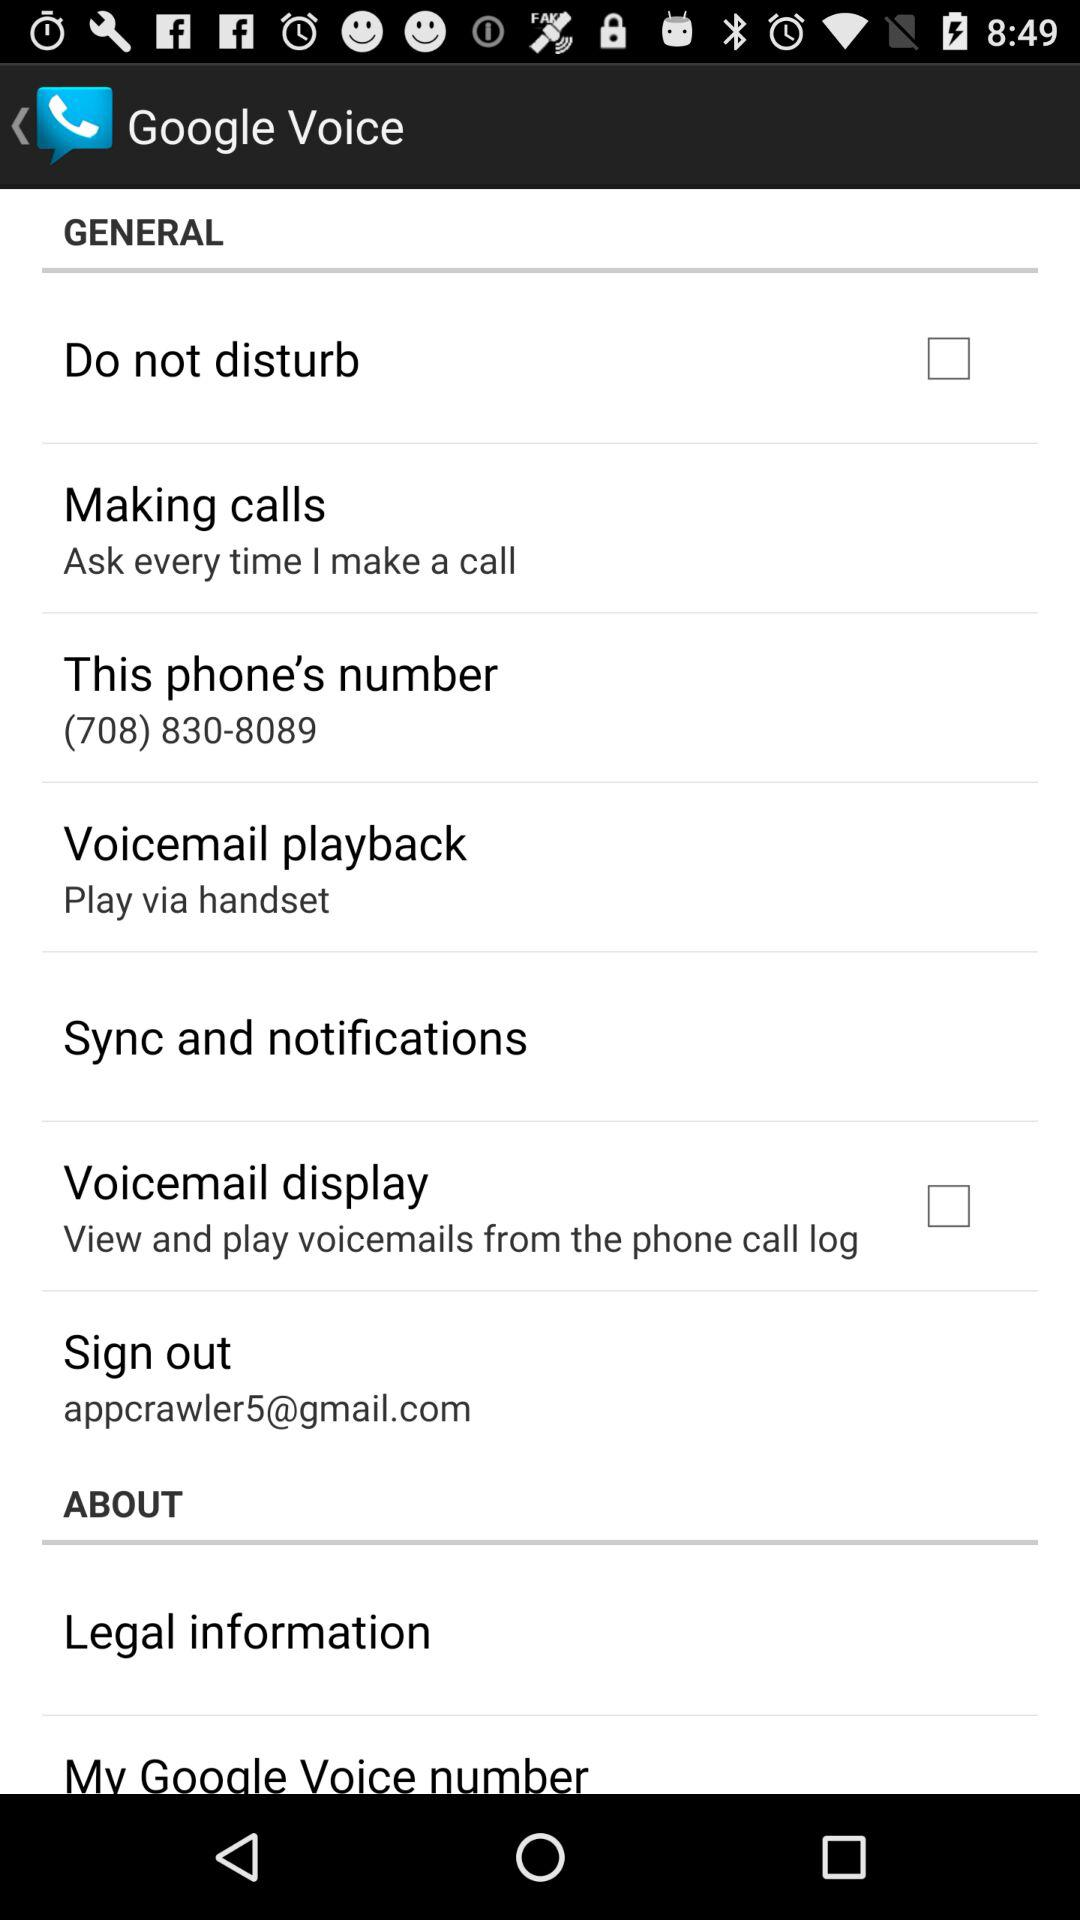What is the status of "Voicemail playback"? The status is "off". 